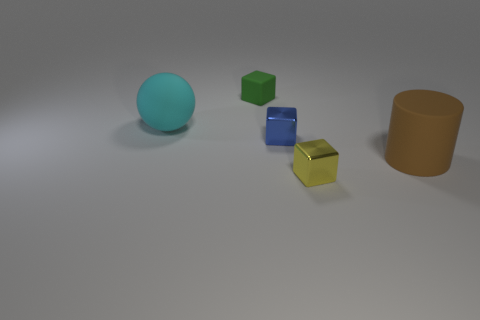Is there any other thing that has the same material as the green cube?
Make the answer very short. Yes. What number of cubes are in front of the cyan sphere and behind the cylinder?
Give a very brief answer. 1. How many things are either tiny objects that are in front of the big brown matte thing or things that are to the right of the cyan rubber thing?
Your answer should be very brief. 4. How many other objects are there of the same shape as the brown thing?
Provide a succinct answer. 0. There is a large thing right of the tiny green cube; is its color the same as the large ball?
Give a very brief answer. No. What number of other things are there of the same size as the green object?
Keep it short and to the point. 2. Does the big cylinder have the same material as the green object?
Provide a succinct answer. Yes. The rubber object to the left of the green cube that is on the left side of the tiny blue thing is what color?
Make the answer very short. Cyan. The yellow metallic thing that is the same shape as the green object is what size?
Offer a very short reply. Small. Is the large sphere the same color as the matte block?
Your response must be concise. No. 